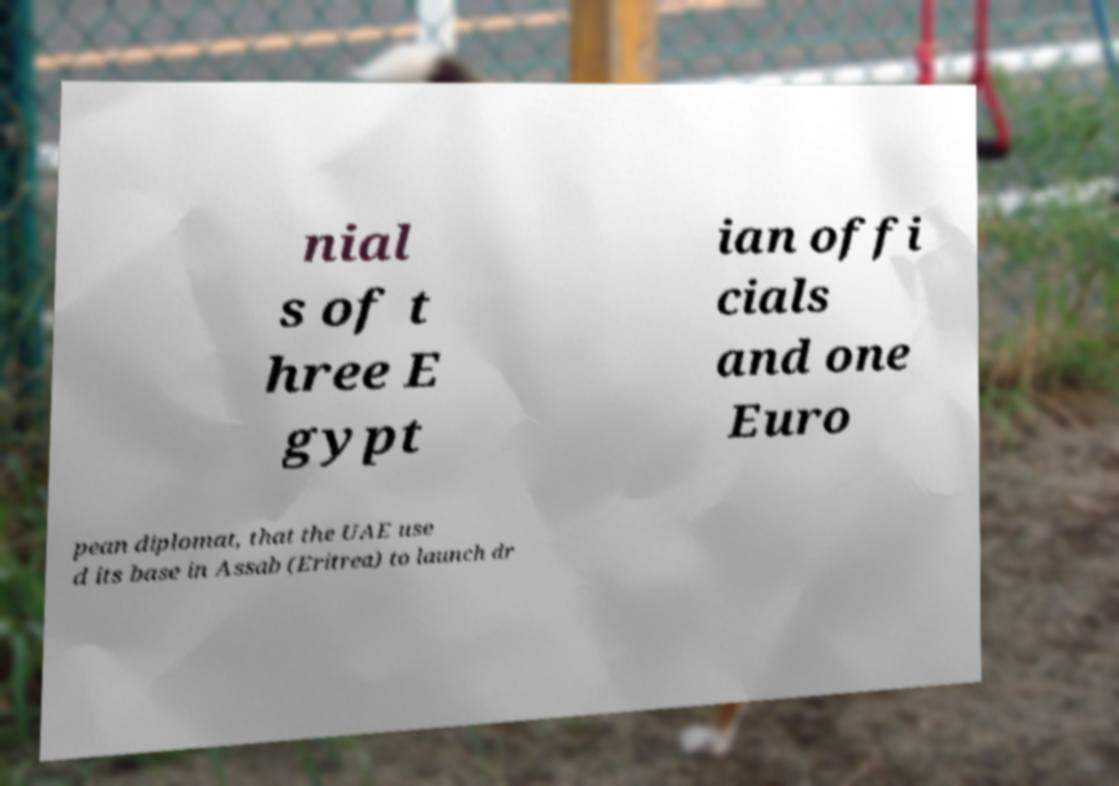For documentation purposes, I need the text within this image transcribed. Could you provide that? nial s of t hree E gypt ian offi cials and one Euro pean diplomat, that the UAE use d its base in Assab (Eritrea) to launch dr 